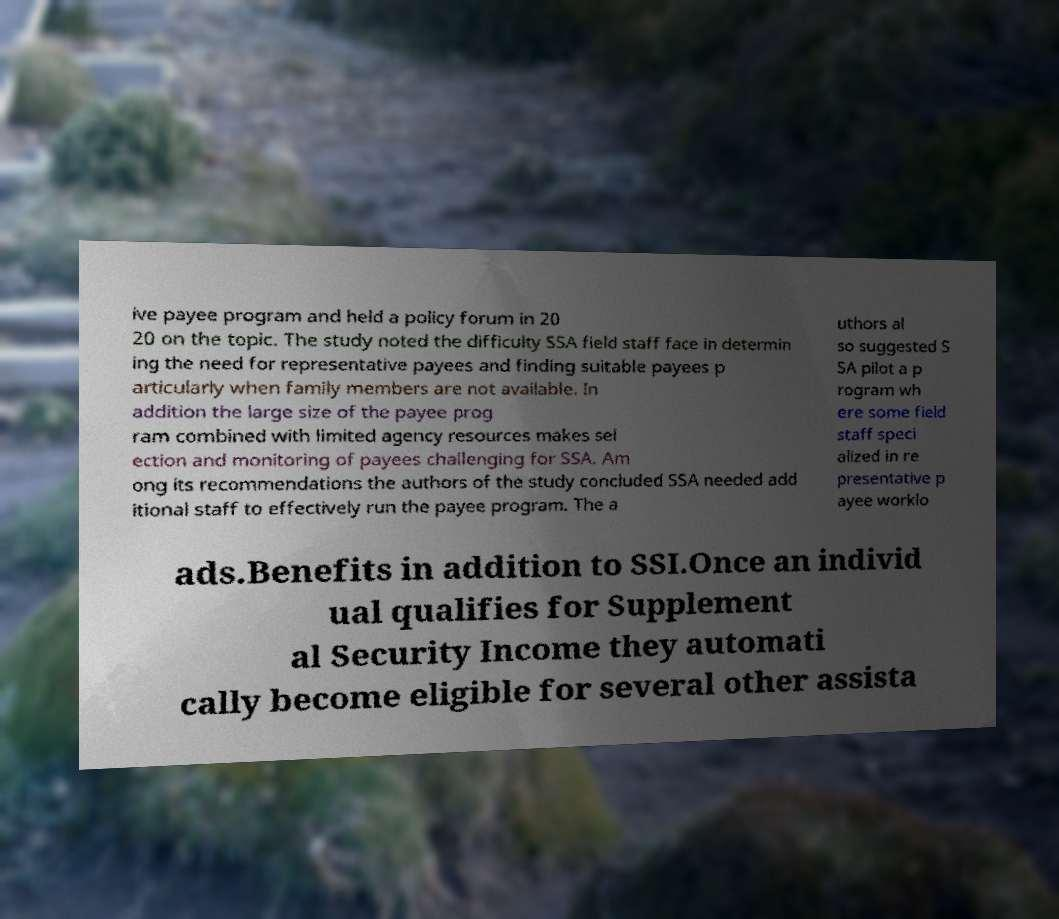What messages or text are displayed in this image? I need them in a readable, typed format. ive payee program and held a policy forum in 20 20 on the topic. The study noted the difficulty SSA field staff face in determin ing the need for representative payees and finding suitable payees p articularly when family members are not available. In addition the large size of the payee prog ram combined with limited agency resources makes sel ection and monitoring of payees challenging for SSA. Am ong its recommendations the authors of the study concluded SSA needed add itional staff to effectively run the payee program. The a uthors al so suggested S SA pilot a p rogram wh ere some field staff speci alized in re presentative p ayee worklo ads.Benefits in addition to SSI.Once an individ ual qualifies for Supplement al Security Income they automati cally become eligible for several other assista 